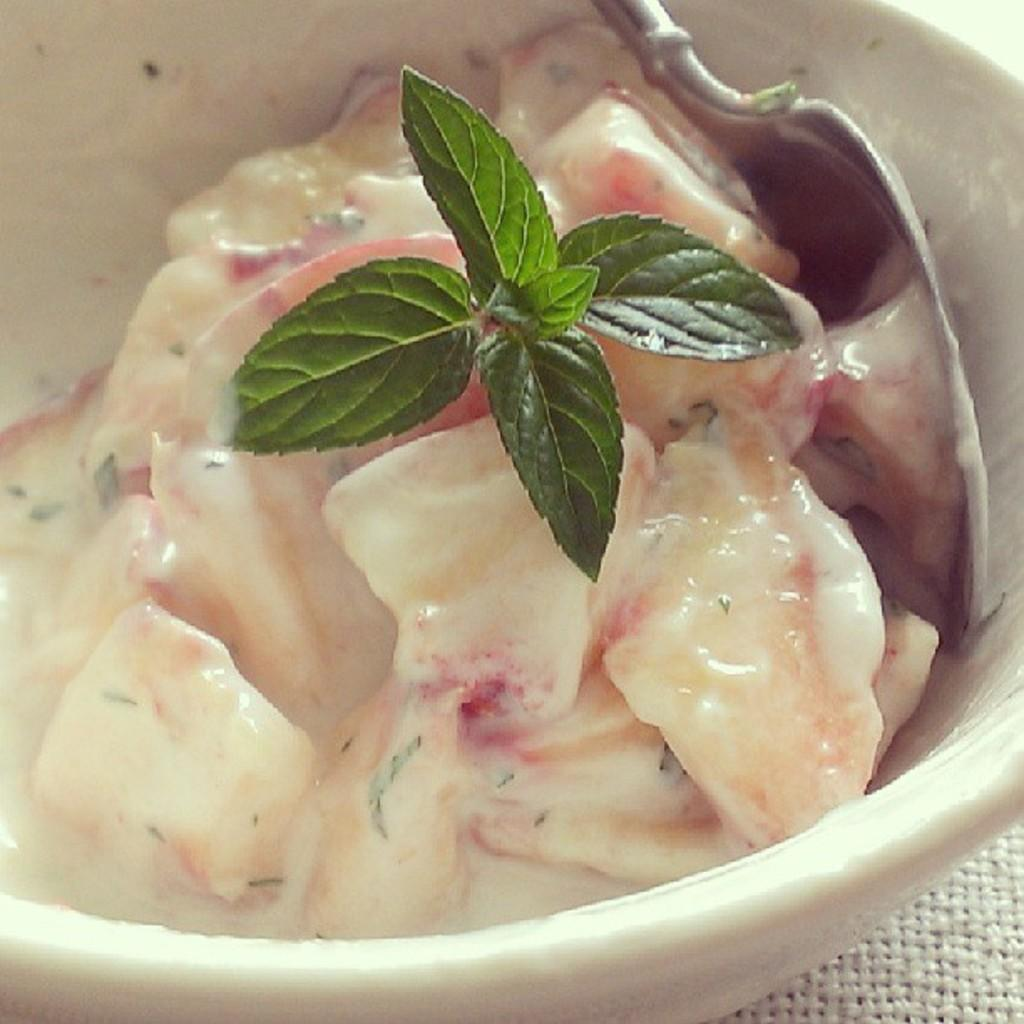What type of objects can be seen in the image? There are food items in the image. What utensil is present in the image? There is a spoon in the image. Where is the spoon located in the image? The spoon is in a bowl. What type of trick can be seen being performed with the spoon in the image? There is no trick being performed with the spoon in the image; it is simply in a bowl with food items. 